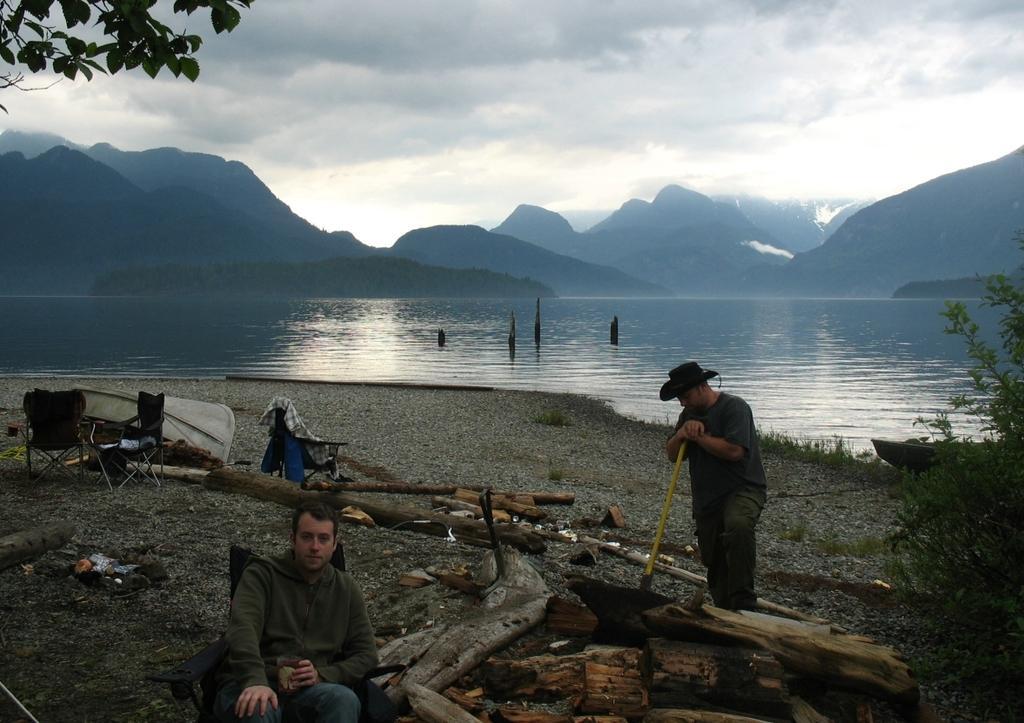Please provide a concise description of this image. The picture is taken near a lake. In the foreground of the picture there are two men, wood, chairs, glass and plants. In the center of the picture there are mountains, lake. At the top to the left there is a stem. Sky is cloudy. 